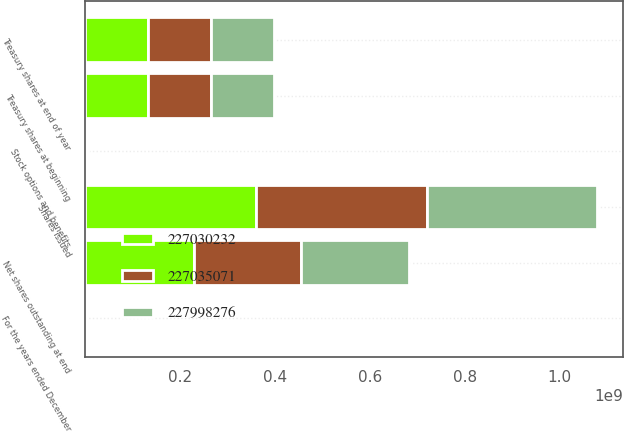<chart> <loc_0><loc_0><loc_500><loc_500><stacked_bar_chart><ecel><fcel>For the years ended December<fcel>Shares issued<fcel>Treasury shares at beginning<fcel>Stock options and benefits<fcel>Treasury shares at end of year<fcel>Net shares outstanding at end<nl><fcel>2.27998e+08<fcel>2010<fcel>3.59902e+08<fcel>1.31903e+08<fcel>3.93237e+06<fcel>1.32872e+08<fcel>2.2703e+08<nl><fcel>2.2703e+08<fcel>2009<fcel>3.59902e+08<fcel>1.32867e+08<fcel>252006<fcel>1.31903e+08<fcel>2.27998e+08<nl><fcel>2.27035e+08<fcel>2008<fcel>3.59902e+08<fcel>1.32852e+08<fcel>1.60961e+06<fcel>1.32867e+08<fcel>2.27035e+08<nl></chart> 